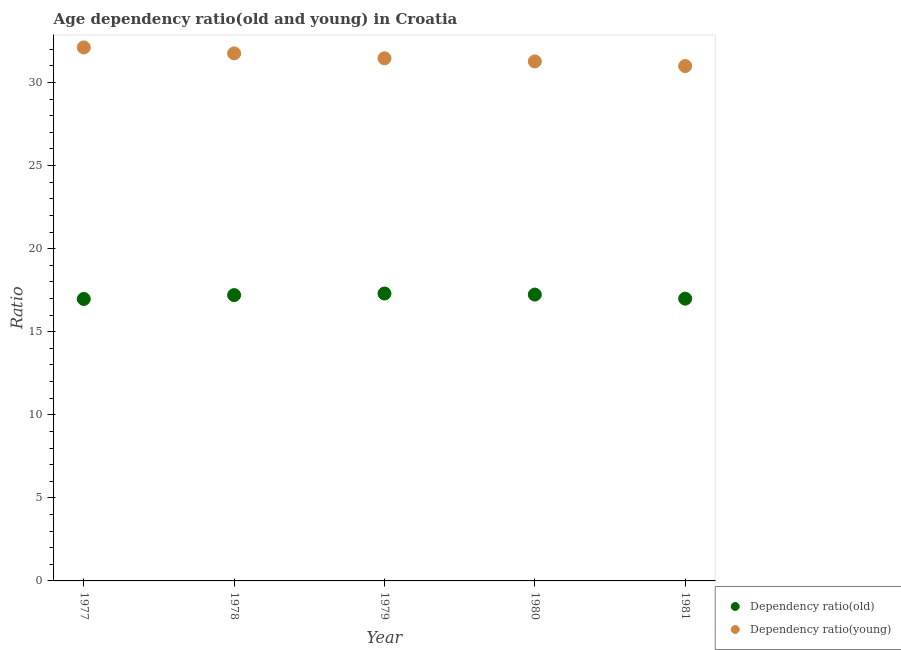How many different coloured dotlines are there?
Ensure brevity in your answer.  2. Is the number of dotlines equal to the number of legend labels?
Give a very brief answer. Yes. What is the age dependency ratio(old) in 1979?
Offer a terse response. 17.3. Across all years, what is the maximum age dependency ratio(young)?
Give a very brief answer. 32.11. Across all years, what is the minimum age dependency ratio(old)?
Keep it short and to the point. 16.97. In which year was the age dependency ratio(old) maximum?
Your answer should be compact. 1979. In which year was the age dependency ratio(young) minimum?
Keep it short and to the point. 1981. What is the total age dependency ratio(old) in the graph?
Provide a short and direct response. 85.69. What is the difference between the age dependency ratio(young) in 1978 and that in 1979?
Keep it short and to the point. 0.3. What is the difference between the age dependency ratio(young) in 1981 and the age dependency ratio(old) in 1977?
Give a very brief answer. 14.02. What is the average age dependency ratio(young) per year?
Offer a very short reply. 31.51. In the year 1978, what is the difference between the age dependency ratio(old) and age dependency ratio(young)?
Give a very brief answer. -14.55. In how many years, is the age dependency ratio(young) greater than 20?
Give a very brief answer. 5. What is the ratio of the age dependency ratio(old) in 1978 to that in 1981?
Your response must be concise. 1.01. Is the difference between the age dependency ratio(old) in 1979 and 1980 greater than the difference between the age dependency ratio(young) in 1979 and 1980?
Provide a short and direct response. No. What is the difference between the highest and the second highest age dependency ratio(old)?
Ensure brevity in your answer.  0.06. What is the difference between the highest and the lowest age dependency ratio(young)?
Offer a very short reply. 1.12. Is the sum of the age dependency ratio(young) in 1978 and 1980 greater than the maximum age dependency ratio(old) across all years?
Your answer should be compact. Yes. How many dotlines are there?
Keep it short and to the point. 2. Are the values on the major ticks of Y-axis written in scientific E-notation?
Provide a short and direct response. No. Does the graph contain any zero values?
Ensure brevity in your answer.  No. Where does the legend appear in the graph?
Give a very brief answer. Bottom right. How many legend labels are there?
Offer a terse response. 2. What is the title of the graph?
Provide a succinct answer. Age dependency ratio(old and young) in Croatia. What is the label or title of the Y-axis?
Provide a short and direct response. Ratio. What is the Ratio of Dependency ratio(old) in 1977?
Offer a very short reply. 16.97. What is the Ratio of Dependency ratio(young) in 1977?
Provide a short and direct response. 32.11. What is the Ratio in Dependency ratio(old) in 1978?
Offer a terse response. 17.2. What is the Ratio in Dependency ratio(young) in 1978?
Provide a short and direct response. 31.75. What is the Ratio of Dependency ratio(old) in 1979?
Keep it short and to the point. 17.3. What is the Ratio of Dependency ratio(young) in 1979?
Give a very brief answer. 31.46. What is the Ratio of Dependency ratio(old) in 1980?
Provide a succinct answer. 17.23. What is the Ratio of Dependency ratio(young) in 1980?
Ensure brevity in your answer.  31.27. What is the Ratio in Dependency ratio(old) in 1981?
Make the answer very short. 16.99. What is the Ratio in Dependency ratio(young) in 1981?
Keep it short and to the point. 30.99. Across all years, what is the maximum Ratio of Dependency ratio(old)?
Provide a succinct answer. 17.3. Across all years, what is the maximum Ratio in Dependency ratio(young)?
Your response must be concise. 32.11. Across all years, what is the minimum Ratio of Dependency ratio(old)?
Your answer should be compact. 16.97. Across all years, what is the minimum Ratio in Dependency ratio(young)?
Your response must be concise. 30.99. What is the total Ratio in Dependency ratio(old) in the graph?
Ensure brevity in your answer.  85.69. What is the total Ratio of Dependency ratio(young) in the graph?
Provide a succinct answer. 157.57. What is the difference between the Ratio in Dependency ratio(old) in 1977 and that in 1978?
Provide a short and direct response. -0.23. What is the difference between the Ratio of Dependency ratio(young) in 1977 and that in 1978?
Provide a succinct answer. 0.36. What is the difference between the Ratio in Dependency ratio(old) in 1977 and that in 1979?
Your answer should be compact. -0.33. What is the difference between the Ratio of Dependency ratio(young) in 1977 and that in 1979?
Make the answer very short. 0.65. What is the difference between the Ratio of Dependency ratio(old) in 1977 and that in 1980?
Give a very brief answer. -0.26. What is the difference between the Ratio of Dependency ratio(young) in 1977 and that in 1980?
Offer a very short reply. 0.84. What is the difference between the Ratio of Dependency ratio(old) in 1977 and that in 1981?
Provide a succinct answer. -0.02. What is the difference between the Ratio in Dependency ratio(young) in 1977 and that in 1981?
Your answer should be very brief. 1.12. What is the difference between the Ratio of Dependency ratio(old) in 1978 and that in 1979?
Offer a terse response. -0.1. What is the difference between the Ratio of Dependency ratio(young) in 1978 and that in 1979?
Ensure brevity in your answer.  0.3. What is the difference between the Ratio of Dependency ratio(old) in 1978 and that in 1980?
Offer a terse response. -0.03. What is the difference between the Ratio of Dependency ratio(young) in 1978 and that in 1980?
Your response must be concise. 0.48. What is the difference between the Ratio of Dependency ratio(old) in 1978 and that in 1981?
Make the answer very short. 0.21. What is the difference between the Ratio in Dependency ratio(young) in 1978 and that in 1981?
Provide a succinct answer. 0.76. What is the difference between the Ratio in Dependency ratio(old) in 1979 and that in 1980?
Your answer should be very brief. 0.06. What is the difference between the Ratio in Dependency ratio(young) in 1979 and that in 1980?
Provide a short and direct response. 0.19. What is the difference between the Ratio in Dependency ratio(old) in 1979 and that in 1981?
Your answer should be compact. 0.31. What is the difference between the Ratio of Dependency ratio(young) in 1979 and that in 1981?
Give a very brief answer. 0.47. What is the difference between the Ratio of Dependency ratio(old) in 1980 and that in 1981?
Your answer should be compact. 0.24. What is the difference between the Ratio in Dependency ratio(young) in 1980 and that in 1981?
Give a very brief answer. 0.28. What is the difference between the Ratio in Dependency ratio(old) in 1977 and the Ratio in Dependency ratio(young) in 1978?
Give a very brief answer. -14.78. What is the difference between the Ratio of Dependency ratio(old) in 1977 and the Ratio of Dependency ratio(young) in 1979?
Offer a very short reply. -14.49. What is the difference between the Ratio in Dependency ratio(old) in 1977 and the Ratio in Dependency ratio(young) in 1980?
Make the answer very short. -14.3. What is the difference between the Ratio of Dependency ratio(old) in 1977 and the Ratio of Dependency ratio(young) in 1981?
Provide a succinct answer. -14.02. What is the difference between the Ratio of Dependency ratio(old) in 1978 and the Ratio of Dependency ratio(young) in 1979?
Make the answer very short. -14.25. What is the difference between the Ratio of Dependency ratio(old) in 1978 and the Ratio of Dependency ratio(young) in 1980?
Make the answer very short. -14.06. What is the difference between the Ratio of Dependency ratio(old) in 1978 and the Ratio of Dependency ratio(young) in 1981?
Give a very brief answer. -13.79. What is the difference between the Ratio of Dependency ratio(old) in 1979 and the Ratio of Dependency ratio(young) in 1980?
Provide a succinct answer. -13.97. What is the difference between the Ratio in Dependency ratio(old) in 1979 and the Ratio in Dependency ratio(young) in 1981?
Your response must be concise. -13.69. What is the difference between the Ratio of Dependency ratio(old) in 1980 and the Ratio of Dependency ratio(young) in 1981?
Your answer should be very brief. -13.76. What is the average Ratio of Dependency ratio(old) per year?
Your response must be concise. 17.14. What is the average Ratio in Dependency ratio(young) per year?
Your answer should be compact. 31.51. In the year 1977, what is the difference between the Ratio in Dependency ratio(old) and Ratio in Dependency ratio(young)?
Ensure brevity in your answer.  -15.14. In the year 1978, what is the difference between the Ratio in Dependency ratio(old) and Ratio in Dependency ratio(young)?
Your answer should be very brief. -14.55. In the year 1979, what is the difference between the Ratio in Dependency ratio(old) and Ratio in Dependency ratio(young)?
Ensure brevity in your answer.  -14.16. In the year 1980, what is the difference between the Ratio in Dependency ratio(old) and Ratio in Dependency ratio(young)?
Keep it short and to the point. -14.03. In the year 1981, what is the difference between the Ratio of Dependency ratio(old) and Ratio of Dependency ratio(young)?
Your response must be concise. -14. What is the ratio of the Ratio of Dependency ratio(old) in 1977 to that in 1978?
Your answer should be very brief. 0.99. What is the ratio of the Ratio of Dependency ratio(young) in 1977 to that in 1978?
Your response must be concise. 1.01. What is the ratio of the Ratio of Dependency ratio(old) in 1977 to that in 1979?
Provide a succinct answer. 0.98. What is the ratio of the Ratio of Dependency ratio(young) in 1977 to that in 1979?
Ensure brevity in your answer.  1.02. What is the ratio of the Ratio of Dependency ratio(old) in 1977 to that in 1980?
Provide a short and direct response. 0.98. What is the ratio of the Ratio of Dependency ratio(young) in 1977 to that in 1980?
Keep it short and to the point. 1.03. What is the ratio of the Ratio of Dependency ratio(old) in 1977 to that in 1981?
Your answer should be very brief. 1. What is the ratio of the Ratio in Dependency ratio(young) in 1977 to that in 1981?
Make the answer very short. 1.04. What is the ratio of the Ratio in Dependency ratio(old) in 1978 to that in 1979?
Make the answer very short. 0.99. What is the ratio of the Ratio of Dependency ratio(young) in 1978 to that in 1979?
Keep it short and to the point. 1.01. What is the ratio of the Ratio of Dependency ratio(old) in 1978 to that in 1980?
Offer a terse response. 1. What is the ratio of the Ratio in Dependency ratio(young) in 1978 to that in 1980?
Ensure brevity in your answer.  1.02. What is the ratio of the Ratio of Dependency ratio(old) in 1978 to that in 1981?
Your response must be concise. 1.01. What is the ratio of the Ratio of Dependency ratio(young) in 1978 to that in 1981?
Offer a terse response. 1.02. What is the ratio of the Ratio in Dependency ratio(young) in 1979 to that in 1980?
Your answer should be very brief. 1.01. What is the ratio of the Ratio of Dependency ratio(old) in 1979 to that in 1981?
Offer a terse response. 1.02. What is the ratio of the Ratio in Dependency ratio(young) in 1979 to that in 1981?
Your response must be concise. 1.02. What is the ratio of the Ratio in Dependency ratio(old) in 1980 to that in 1981?
Give a very brief answer. 1.01. What is the ratio of the Ratio in Dependency ratio(young) in 1980 to that in 1981?
Ensure brevity in your answer.  1.01. What is the difference between the highest and the second highest Ratio of Dependency ratio(old)?
Provide a short and direct response. 0.06. What is the difference between the highest and the second highest Ratio of Dependency ratio(young)?
Keep it short and to the point. 0.36. What is the difference between the highest and the lowest Ratio of Dependency ratio(old)?
Your answer should be very brief. 0.33. What is the difference between the highest and the lowest Ratio in Dependency ratio(young)?
Make the answer very short. 1.12. 